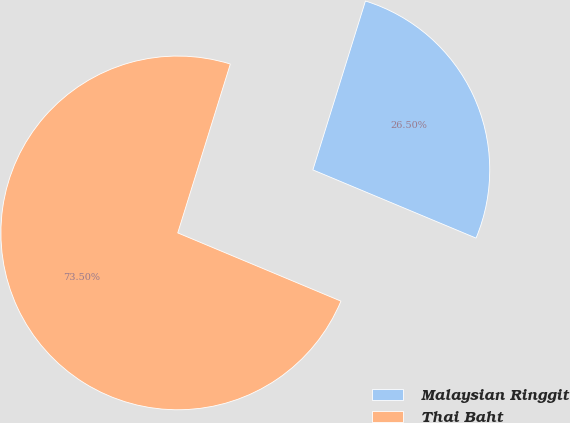<chart> <loc_0><loc_0><loc_500><loc_500><pie_chart><fcel>Malaysian Ringgit<fcel>Thai Baht<nl><fcel>26.5%<fcel>73.5%<nl></chart> 